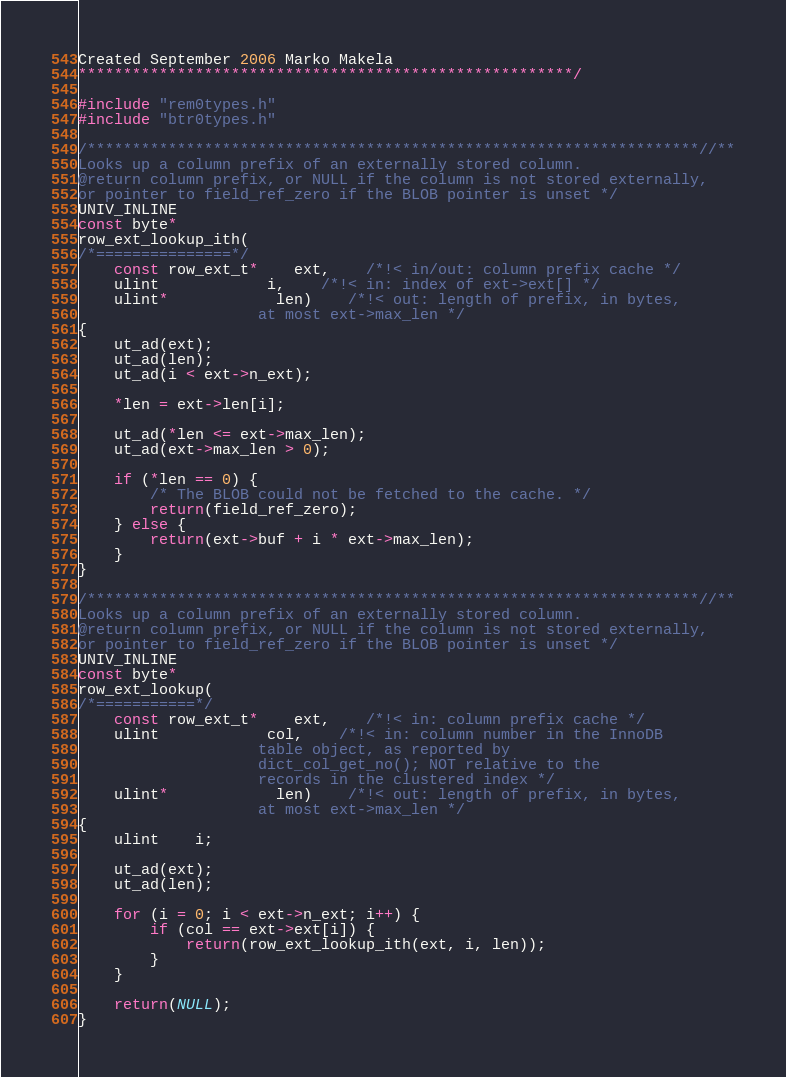<code> <loc_0><loc_0><loc_500><loc_500><_C++_>Created September 2006 Marko Makela
*******************************************************/

#include "rem0types.h"
#include "btr0types.h"

/********************************************************************//**
Looks up a column prefix of an externally stored column.
@return column prefix, or NULL if the column is not stored externally,
or pointer to field_ref_zero if the BLOB pointer is unset */
UNIV_INLINE
const byte*
row_ext_lookup_ith(
/*===============*/
	const row_ext_t*	ext,	/*!< in/out: column prefix cache */
	ulint			i,	/*!< in: index of ext->ext[] */
	ulint*			len)	/*!< out: length of prefix, in bytes,
					at most ext->max_len */
{
	ut_ad(ext);
	ut_ad(len);
	ut_ad(i < ext->n_ext);

	*len = ext->len[i];

	ut_ad(*len <= ext->max_len);
	ut_ad(ext->max_len > 0);

	if (*len == 0) {
		/* The BLOB could not be fetched to the cache. */
		return(field_ref_zero);
	} else {
		return(ext->buf + i * ext->max_len);
	}
}

/********************************************************************//**
Looks up a column prefix of an externally stored column.
@return column prefix, or NULL if the column is not stored externally,
or pointer to field_ref_zero if the BLOB pointer is unset */
UNIV_INLINE
const byte*
row_ext_lookup(
/*===========*/
	const row_ext_t*	ext,	/*!< in: column prefix cache */
	ulint			col,	/*!< in: column number in the InnoDB
					table object, as reported by
					dict_col_get_no(); NOT relative to the
					records in the clustered index */
	ulint*			len)	/*!< out: length of prefix, in bytes,
					at most ext->max_len */
{
	ulint	i;

	ut_ad(ext);
	ut_ad(len);

	for (i = 0; i < ext->n_ext; i++) {
		if (col == ext->ext[i]) {
			return(row_ext_lookup_ith(ext, i, len));
		}
	}

	return(NULL);
}
</code> 